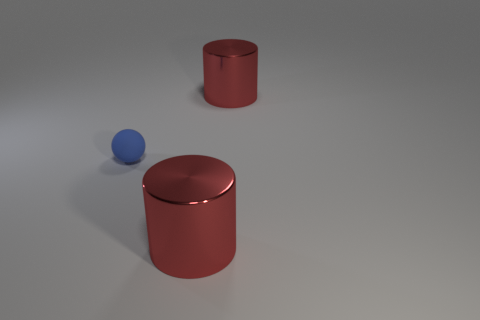There is a red metallic cylinder that is to the left of the red thing to the right of the cylinder that is in front of the blue object; what size is it?
Give a very brief answer. Large. Do the red shiny thing in front of the blue ball and the big thing that is behind the tiny object have the same shape?
Keep it short and to the point. Yes. Are there any red metallic cylinders that are left of the thing in front of the tiny blue object?
Your response must be concise. No. Are there any large metal things?
Your response must be concise. Yes. What number of big metal things are both in front of the ball and behind the tiny matte thing?
Offer a very short reply. 0. There is a object that is behind the matte object; is its size the same as the small sphere?
Offer a terse response. No. How many other things are there of the same material as the small thing?
Ensure brevity in your answer.  0. What is the shape of the blue thing?
Offer a terse response. Sphere. Are there more metal things that are in front of the small blue rubber thing than big gray metallic cubes?
Give a very brief answer. Yes. Is there any other thing that is the same shape as the blue thing?
Your response must be concise. No. 